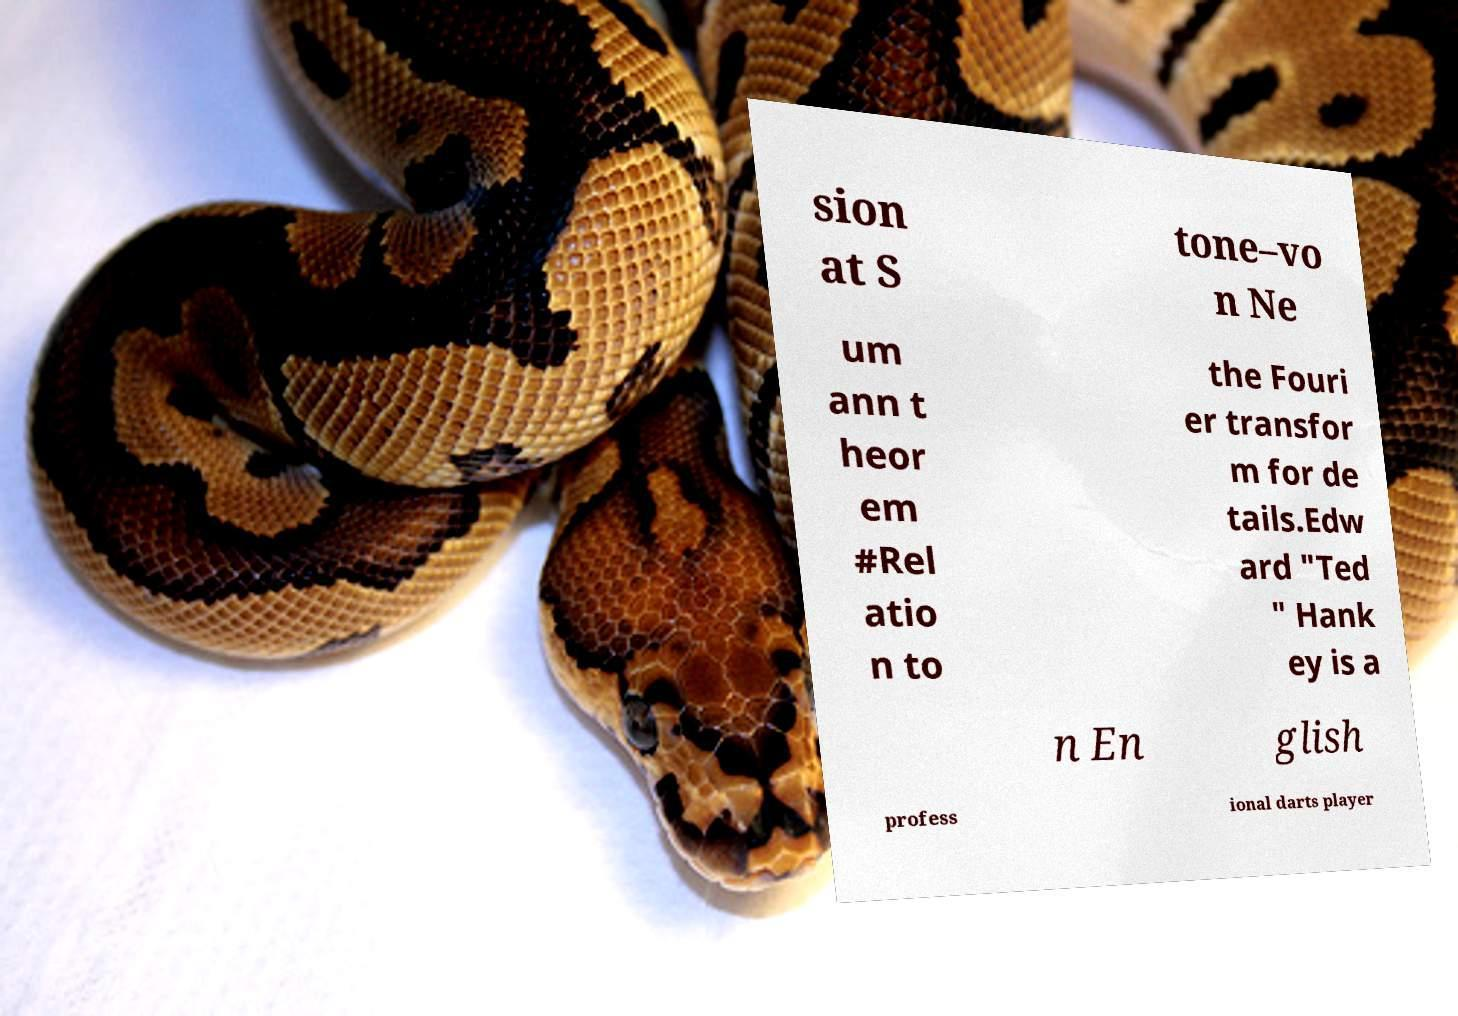I need the written content from this picture converted into text. Can you do that? sion at S tone–vo n Ne um ann t heor em #Rel atio n to the Fouri er transfor m for de tails.Edw ard "Ted " Hank ey is a n En glish profess ional darts player 